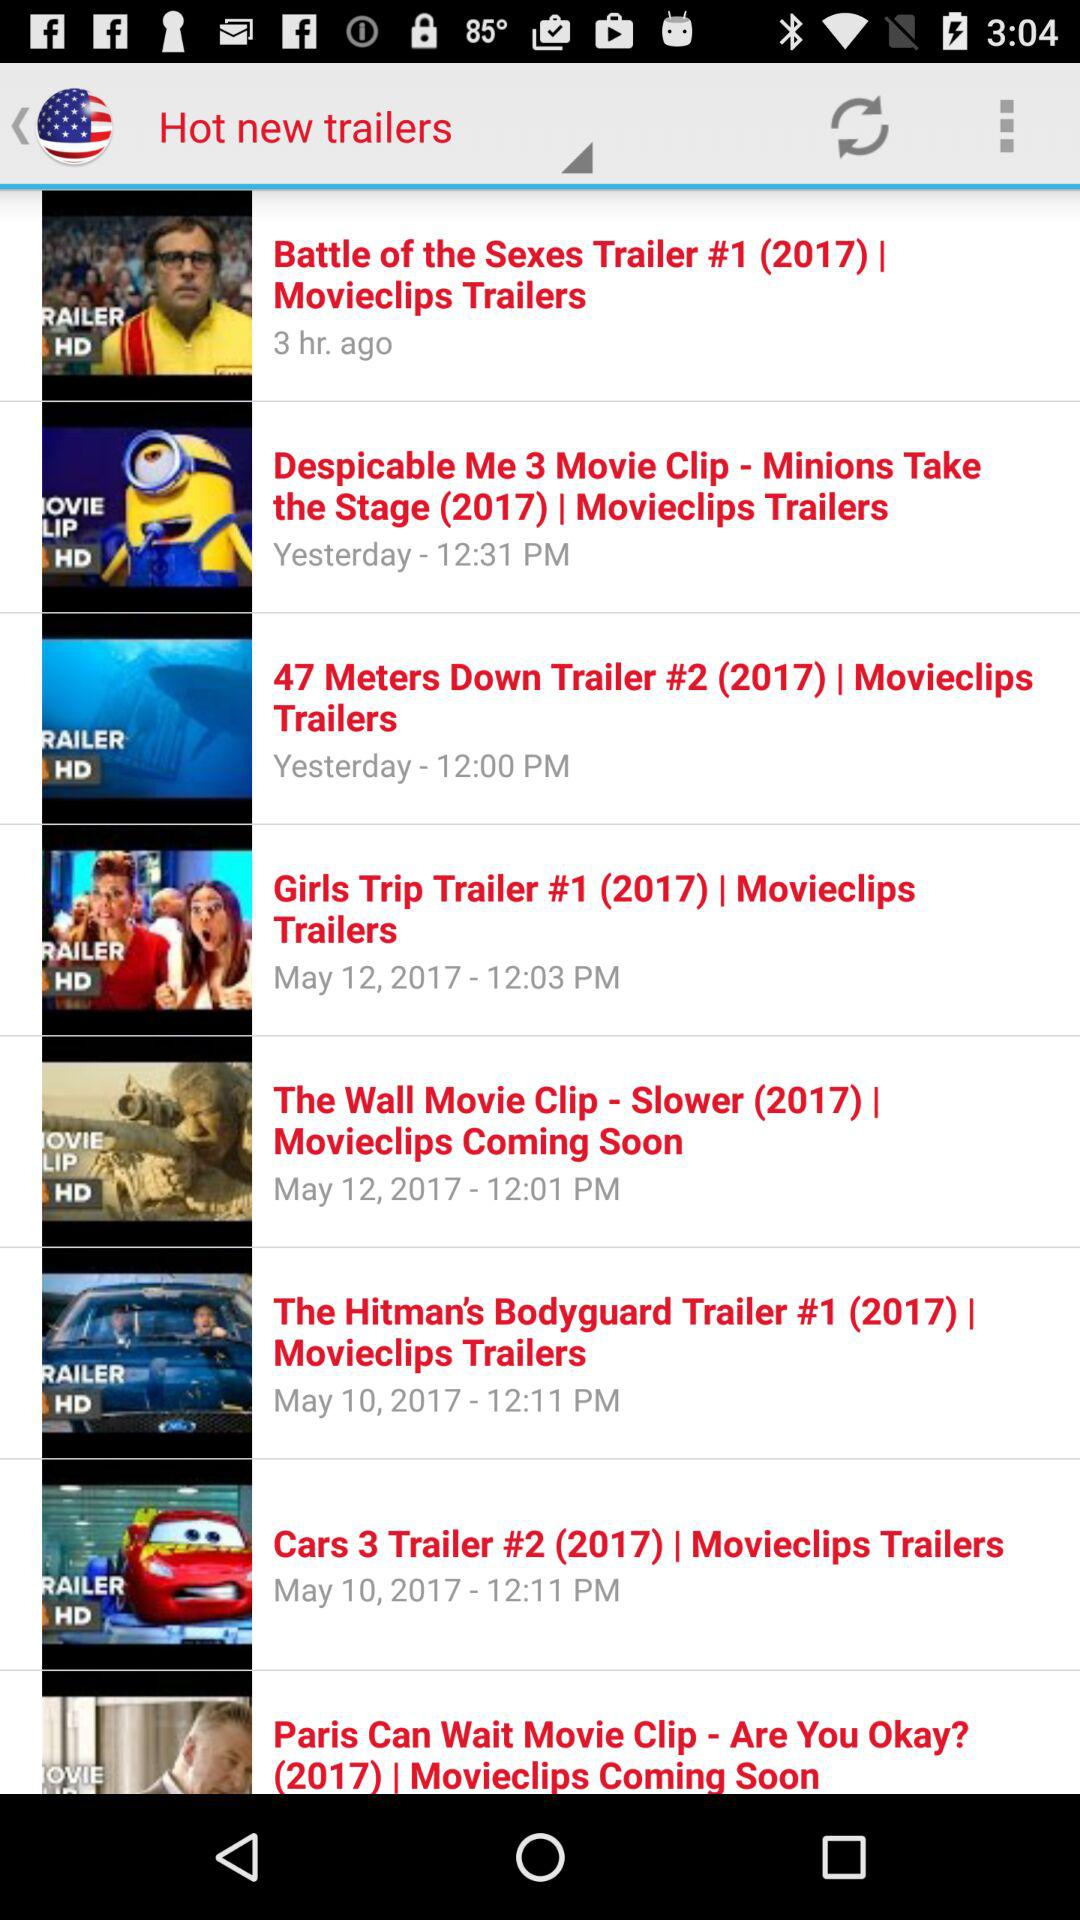On which date was "The Hitman's Bodyguard" trailer launched? The trailer was launched on May 10, 2017. 